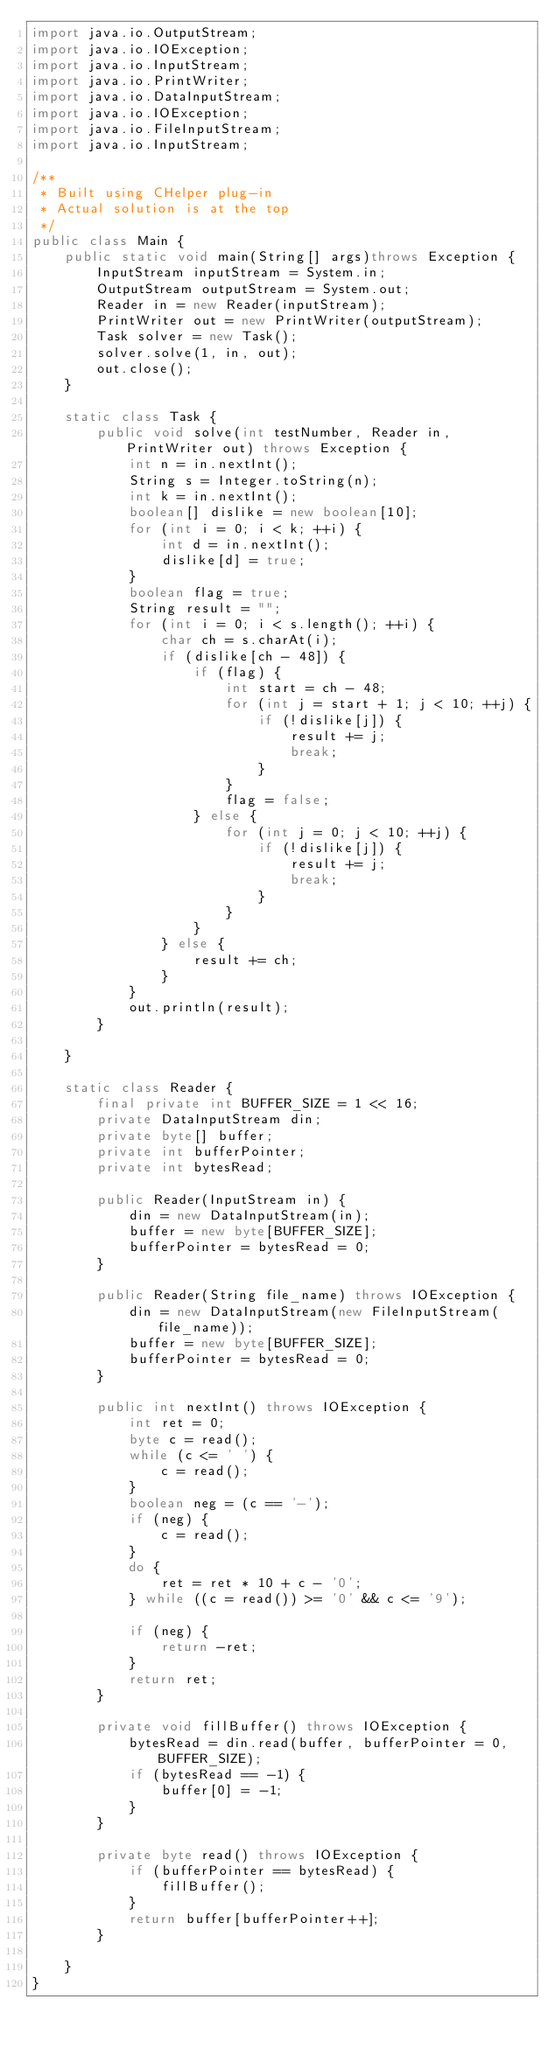Convert code to text. <code><loc_0><loc_0><loc_500><loc_500><_Java_>import java.io.OutputStream;
import java.io.IOException;
import java.io.InputStream;
import java.io.PrintWriter;
import java.io.DataInputStream;
import java.io.IOException;
import java.io.FileInputStream;
import java.io.InputStream;

/**
 * Built using CHelper plug-in
 * Actual solution is at the top
 */
public class Main {
    public static void main(String[] args)throws Exception {
        InputStream inputStream = System.in;
        OutputStream outputStream = System.out;
        Reader in = new Reader(inputStream);
        PrintWriter out = new PrintWriter(outputStream);
        Task solver = new Task();
        solver.solve(1, in, out);
        out.close();
    }

    static class Task {
        public void solve(int testNumber, Reader in, PrintWriter out) throws Exception {
            int n = in.nextInt();
            String s = Integer.toString(n);
            int k = in.nextInt();
            boolean[] dislike = new boolean[10];
            for (int i = 0; i < k; ++i) {
                int d = in.nextInt();
                dislike[d] = true;
            }
            boolean flag = true;
            String result = "";
            for (int i = 0; i < s.length(); ++i) {
                char ch = s.charAt(i);
                if (dislike[ch - 48]) {
                    if (flag) {
                        int start = ch - 48;
                        for (int j = start + 1; j < 10; ++j) {
                            if (!dislike[j]) {
                                result += j;
                                break;
                            }
                        }
                        flag = false;
                    } else {
                        for (int j = 0; j < 10; ++j) {
                            if (!dislike[j]) {
                                result += j;
                                break;
                            }
                        }
                    }
                } else {
                    result += ch;
                }
            }
            out.println(result);
        }

    }

    static class Reader {
        final private int BUFFER_SIZE = 1 << 16;
        private DataInputStream din;
        private byte[] buffer;
        private int bufferPointer;
        private int bytesRead;

        public Reader(InputStream in) {
            din = new DataInputStream(in);
            buffer = new byte[BUFFER_SIZE];
            bufferPointer = bytesRead = 0;
        }

        public Reader(String file_name) throws IOException {
            din = new DataInputStream(new FileInputStream(file_name));
            buffer = new byte[BUFFER_SIZE];
            bufferPointer = bytesRead = 0;
        }

        public int nextInt() throws IOException {
            int ret = 0;
            byte c = read();
            while (c <= ' ') {
                c = read();
            }
            boolean neg = (c == '-');
            if (neg) {
                c = read();
            }
            do {
                ret = ret * 10 + c - '0';
            } while ((c = read()) >= '0' && c <= '9');

            if (neg) {
                return -ret;
            }
            return ret;
        }

        private void fillBuffer() throws IOException {
            bytesRead = din.read(buffer, bufferPointer = 0, BUFFER_SIZE);
            if (bytesRead == -1) {
                buffer[0] = -1;
            }
        }

        private byte read() throws IOException {
            if (bufferPointer == bytesRead) {
                fillBuffer();
            }
            return buffer[bufferPointer++];
        }

    }
}

</code> 